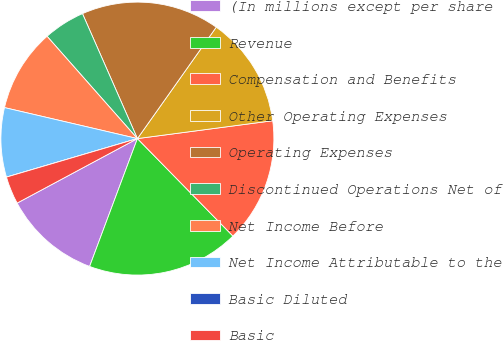<chart> <loc_0><loc_0><loc_500><loc_500><pie_chart><fcel>(In millions except per share<fcel>Revenue<fcel>Compensation and Benefits<fcel>Other Operating Expenses<fcel>Operating Expenses<fcel>Discontinued Operations Net of<fcel>Net Income Before<fcel>Net Income Attributable to the<fcel>Basic Diluted<fcel>Basic<nl><fcel>11.47%<fcel>18.03%<fcel>14.75%<fcel>13.11%<fcel>16.39%<fcel>4.92%<fcel>9.84%<fcel>8.2%<fcel>0.0%<fcel>3.28%<nl></chart> 